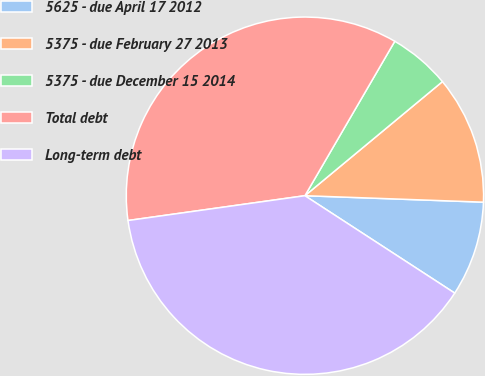Convert chart. <chart><loc_0><loc_0><loc_500><loc_500><pie_chart><fcel>5625 - due April 17 2012<fcel>5375 - due February 27 2013<fcel>5375 - due December 15 2014<fcel>Total debt<fcel>Long-term debt<nl><fcel>8.6%<fcel>11.6%<fcel>5.59%<fcel>35.61%<fcel>38.61%<nl></chart> 